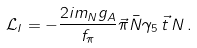<formula> <loc_0><loc_0><loc_500><loc_500>\mathcal { L } _ { I } = - \frac { 2 i m _ { N } g _ { A } } { f _ { \pi } } \vec { \pi } \bar { N } \gamma _ { 5 } \, \vec { t } \, N \, .</formula> 